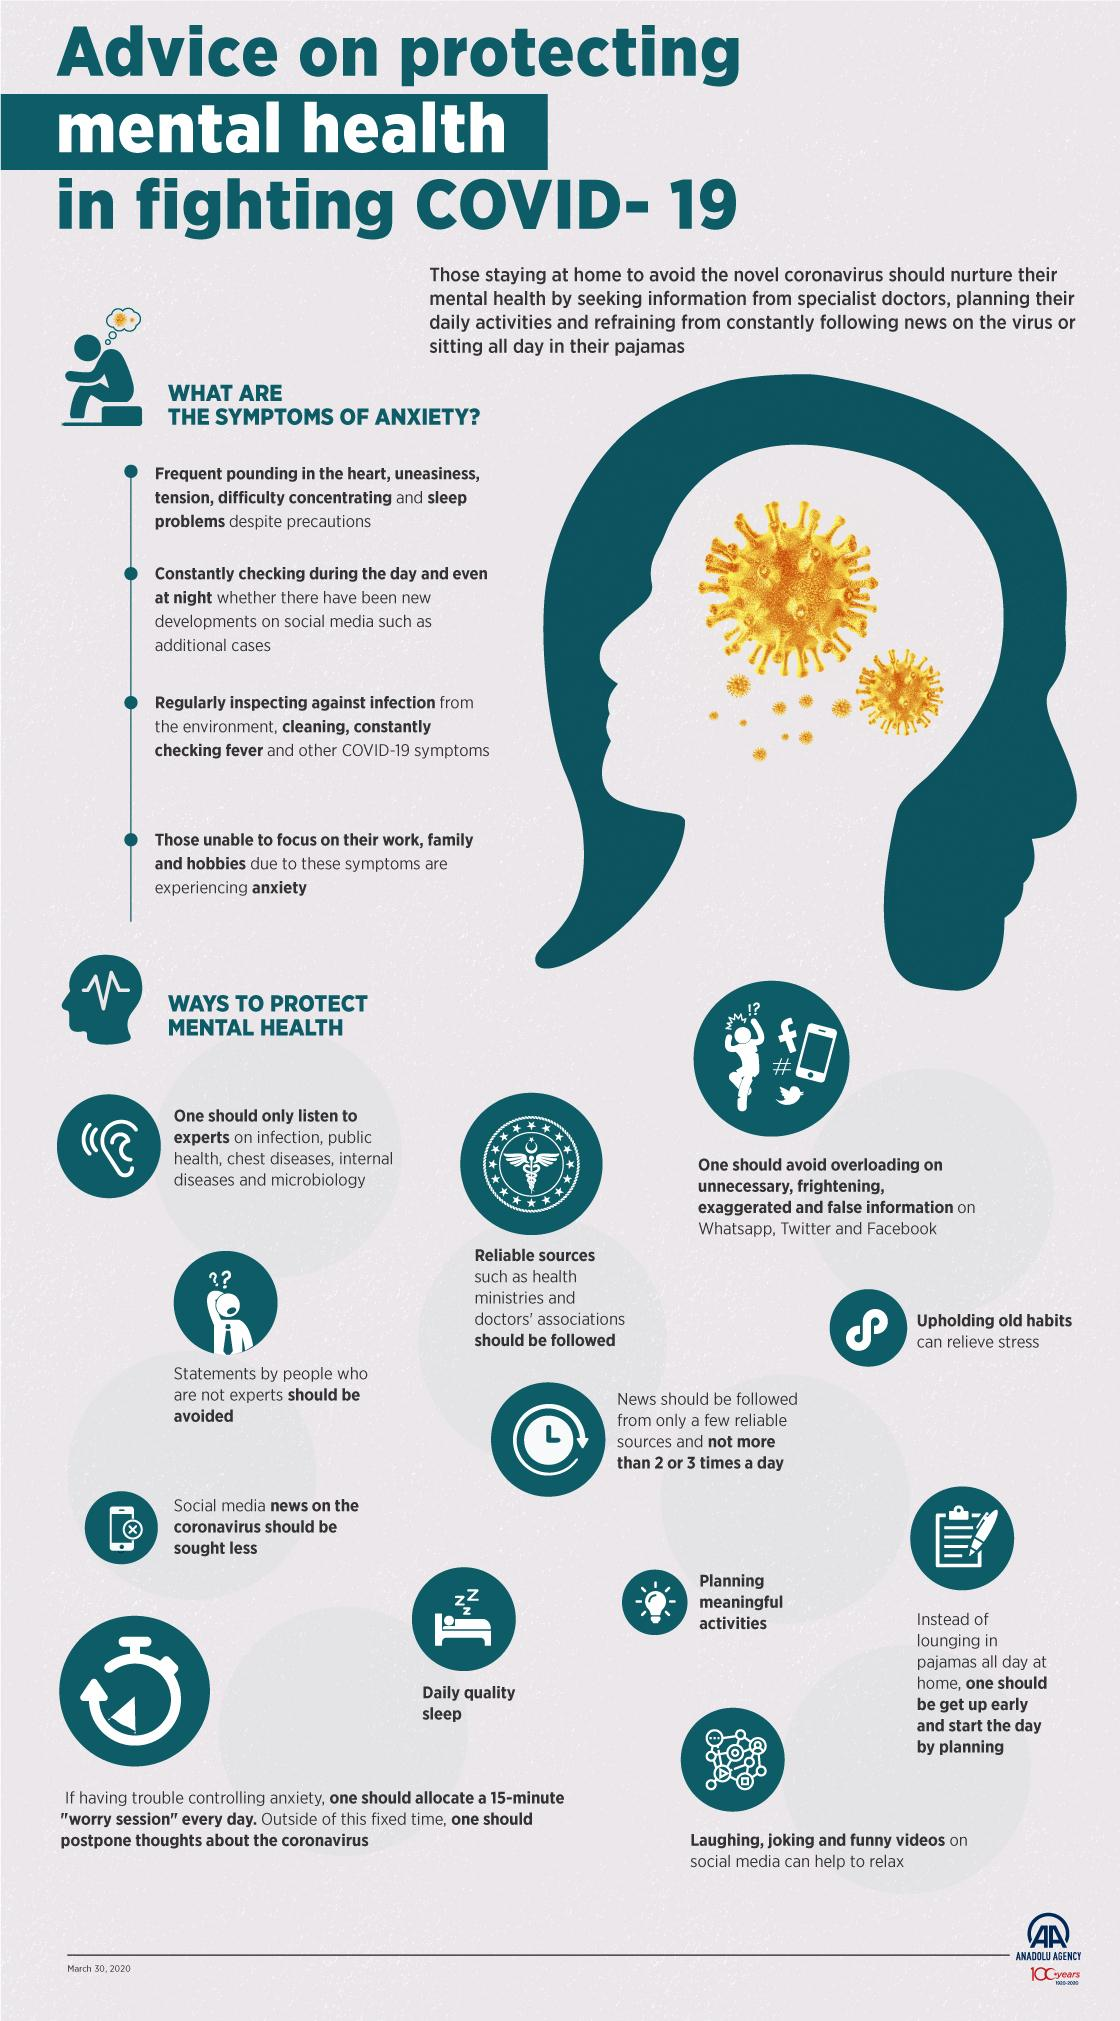List a handful of essential elements in this visual. The source of information on public health infections and other diseases that we should trust is the opinion of experts. It is advisable to follow reliable sources of information, such as health ministries and doctors' associations. Upholding old habits can help relieve stress by providing a sense of security and familiarity in a time of change. There are four bullet points under the symptoms of anxiety. The mental health strategy represented by the picture of a bulb is planning meaningful activities. 